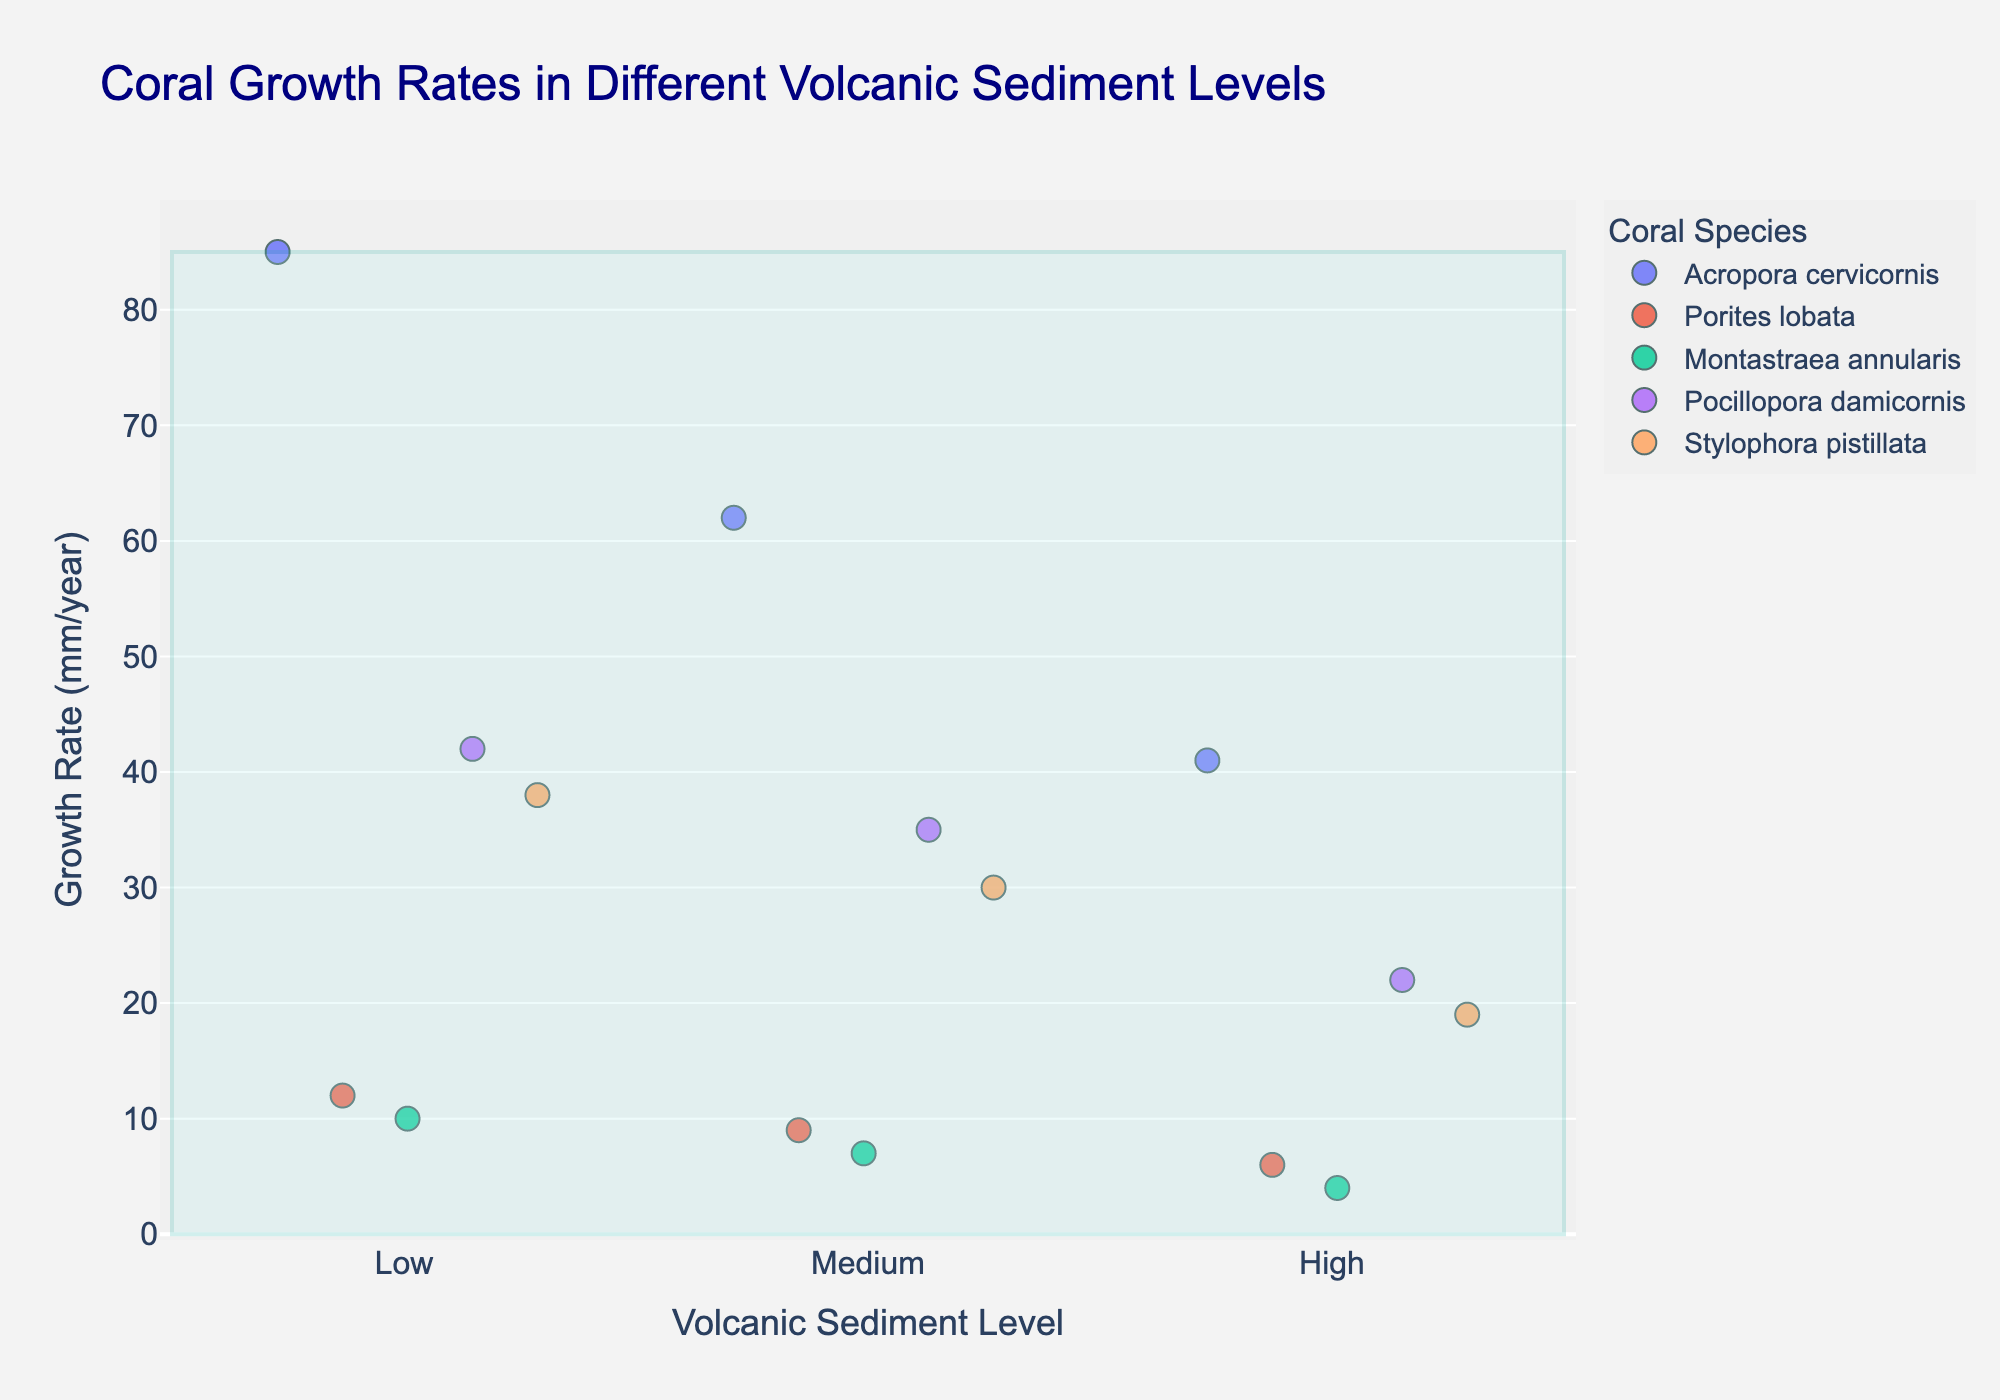What is the title of the plot? The title of the plot is typically displayed at the top of the figure.
Answer: Coral Growth Rates in Different Volcanic Sediment Levels Which coral species shows the highest growth rate in low volcanic sediment levels? Check the highest y-value (Growth Rate) in the 'Low' sediment level category and identify the corresponding coral species from the color legend.
Answer: Acropora cervicornis How does the growth rate of Porites lobata change as volcanic sediment levels increase? Observe the y-values (Growth Rate) for Porites lobata across 'Low', 'Medium', and 'High' categories and compare them.
Answer: It decreases from 12 to 9 to 6 mm/year Which coral species has the most significant drop in growth rate from low to high volcanic sediment levels? Calculate the difference in growth rates between 'Low' and 'High' sediment levels for each species and identify the largest drop. Detailed steps: 85-41=44 for Acropora cervicornis, 12-6=6 for Porites lobata, 10-4=6 for Montastraea annularis, 42-22=20 for Pocillopora damicornis, 38-19=19 for Stylophora pistillata.
Answer: Acropora cervicornis What is the average growth rate for Montastraea annularis across all sediment levels? Sum the growth rates of Montastraea annularis for 'Low', 'Medium', and 'High' levels and divide by three. Calculation: (10+7+4)/3.
Answer: 7 mm/year Which sediment level category shows the most significant variance in growth rates? Compare the spread of the y-values within each sediment level category by visually assessing the range covered by the points.
Answer: Low Does any coral species have a constant difference in growth rates between subsequent sediment levels? Assess the differences between growth rates at 'Low' and 'Medium', and 'Medium' and 'High' levels for each species and check for uniformity.
Answer: None Which coral species shows the least impact of volcanic sediment levels on its growth rate? Determine which species has the smallest overall change in growth rates across 'Low', 'Medium', and 'High' levels.
Answer: Porites lobata (6 mm/year difference) How does the growth rate of Pocillopora damicornis in medium sediment levels compare to Stylophora pistillata in high sediment levels? Compare the y-values of Pocillopora damicornis at the 'Medium' level and Stylophora pistillata at the 'High' level.
Answer: Pocillopora damicornis has a higher growth rate (35 mm/year vs. 19 mm/year) What is the median growth rate of all coral species at high volcanic sediment levels? Arrange the growth rates of all coral species at 'High' levels in ascending order and find the middle value. Sorted: 4, 6, 19, 22, 41 (median: 19)
Answer: 19 mm/year 